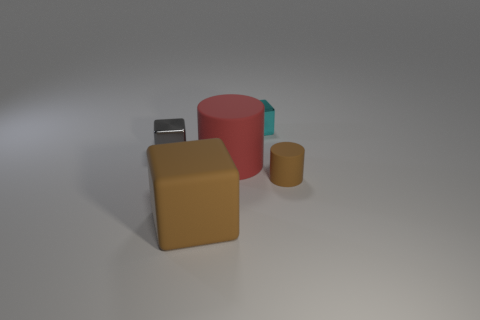How many other things are the same shape as the tiny brown rubber thing? There is one other object that shares the same cylindrical shape as the tiny brown rubber-like item. It's the larger red cylinder to the right in the image. 